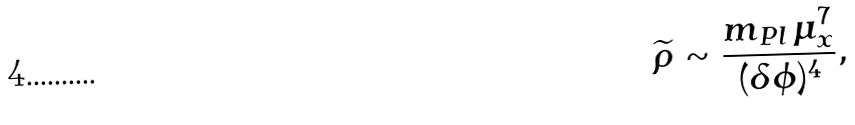<formula> <loc_0><loc_0><loc_500><loc_500>\widetilde { \rho } \sim \frac { m _ { P l } \, \mu _ { x } ^ { 7 } } { ( \delta \phi ) ^ { 4 } } ,</formula> 